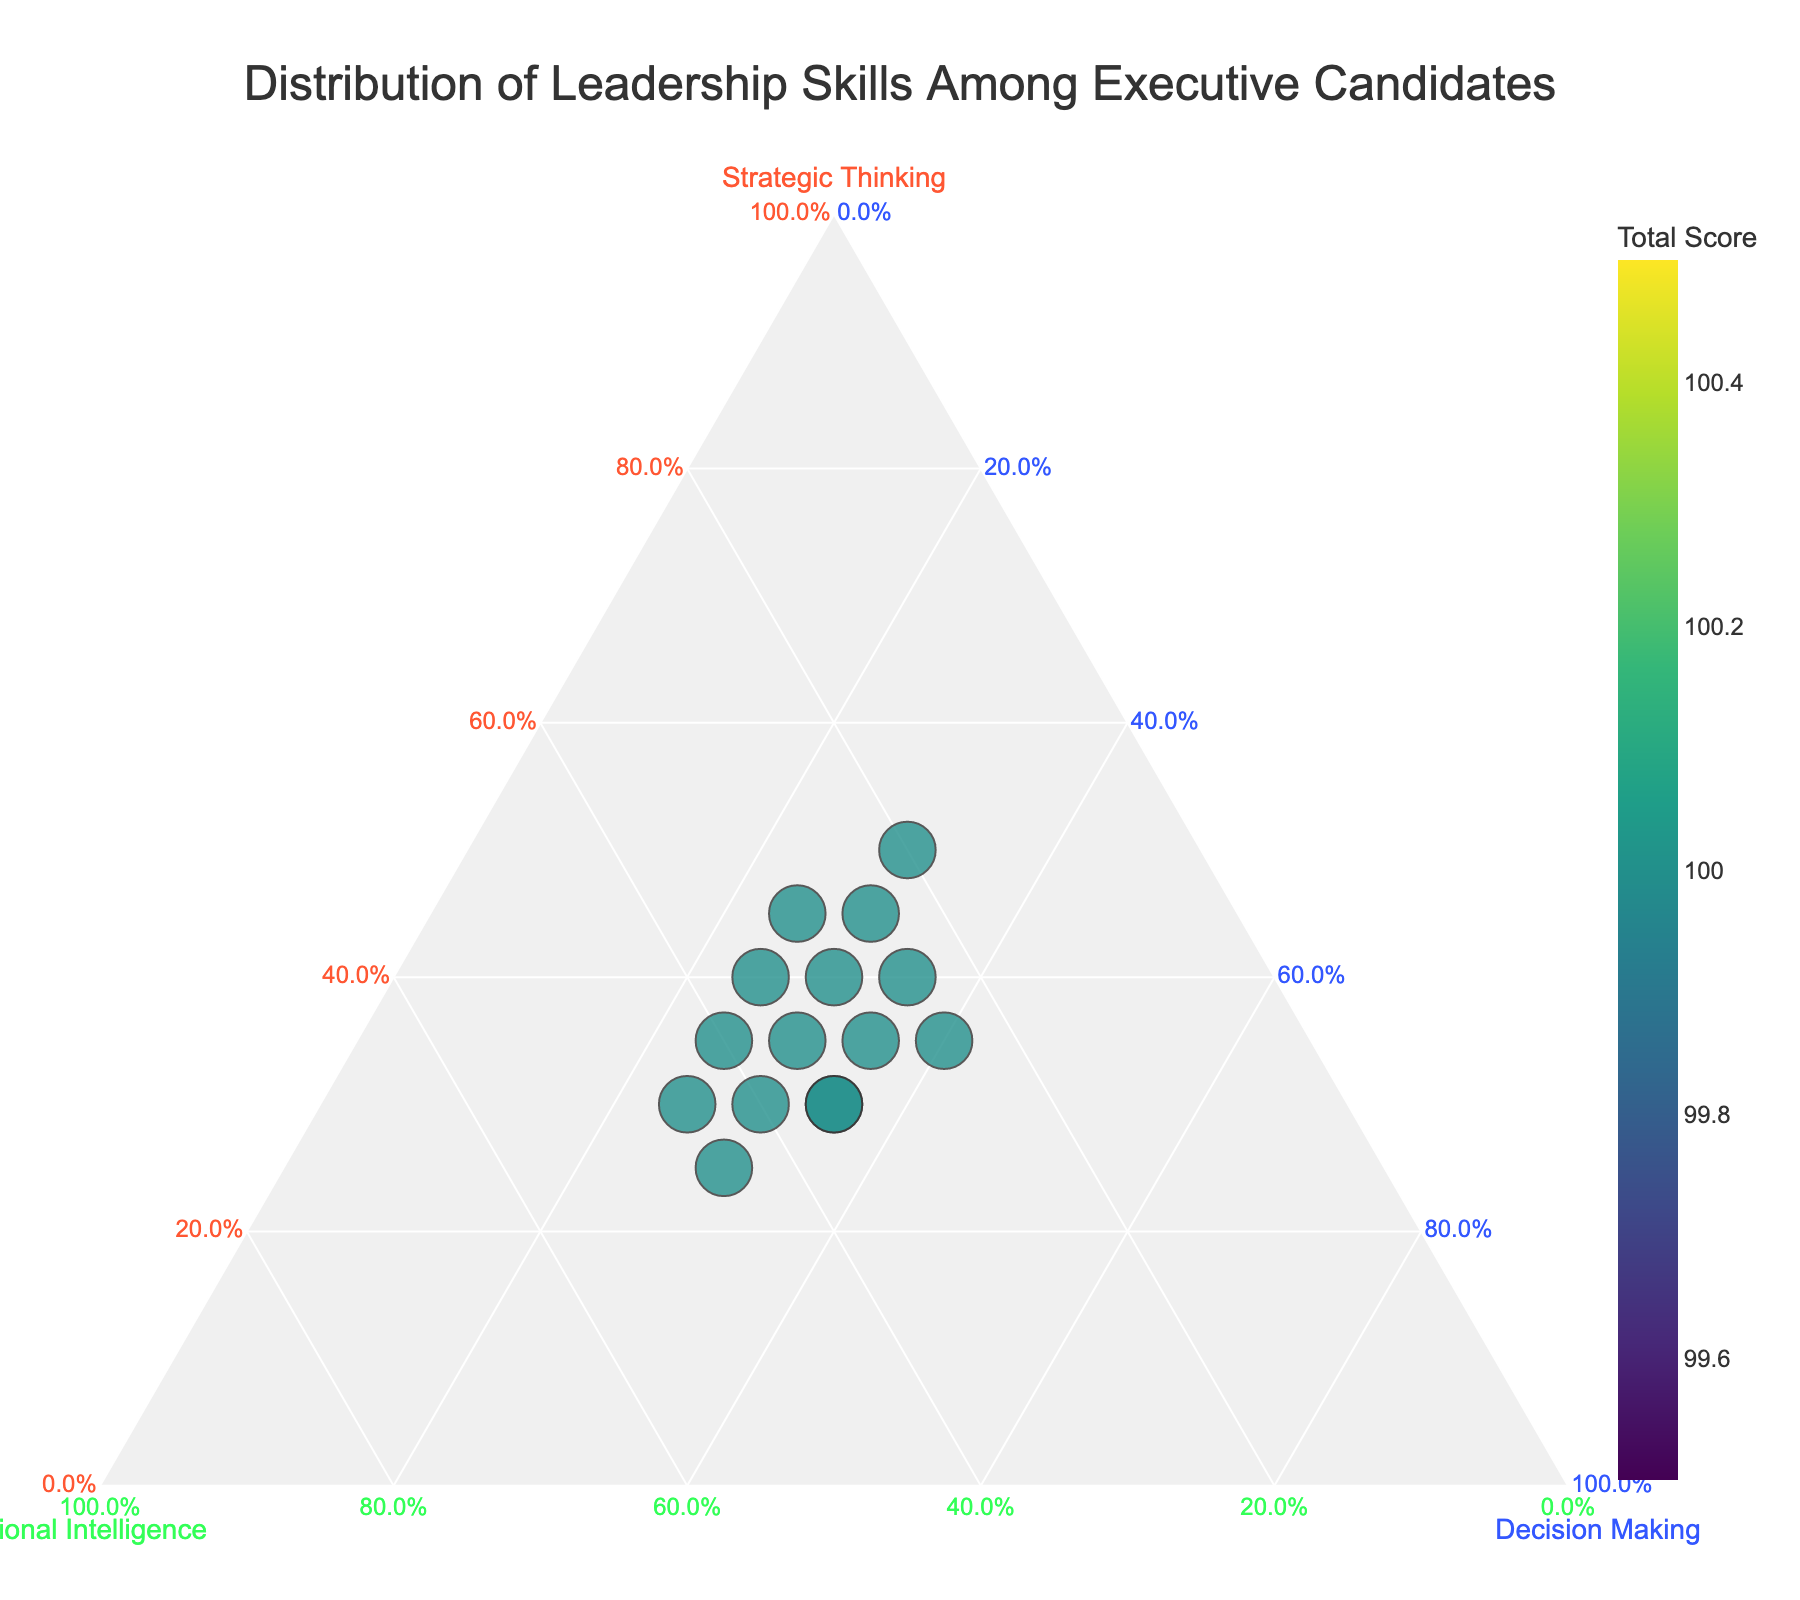What is the title of the plot? The title is prominently displayed at the top of the plot.
Answer: Distribution of Leadership Skills Among Executive Candidates How many total candidates are represented in the plot? The total number of data points (candidates) can be counted from the plot.
Answer: 15 Which axis represents Strategic Thinking? The axis labeled "Strategic Thinking" represents the Strategic Thinking component.
Answer: The left axis Which candidate has the highest combined total score? By checking the color scale and the size of the markers, which correspond to the total score, the candidate with the largest and darkest marker can be identified.
Answer: James Wilson Compare the skills distribution of Sarah Johnson and Michael Chen. Sarah Johnson and Michael Chen's positions on the plot can be examined and compared based on their coordinates on each axis. Sarah's strategic thinking is more prominent, Michael's emotional intelligence is higher, and their decision-making skills are equal.
Answer: Sarah: Higher Strategic Thinking, Michael: Higher Emotional Intelligence, Decision Making: Equal Which candidate has the highest proportion of Emotional Intelligence? By finding the candidate positioned furthest towards the Emotional Intelligence axis, the candidate with the highest proportion can be identified.
Answer: Natalie Kim How does Olivia Patel's skill distribution differ from Emma Garcia's? By locating Olivia Patel and Emma Garcia on the plot and comparing their relative positions to each axis. Olivia has equal strategic thinking and emotional intelligence, while Emma has higher strategic thinking.
Answer: Olivia: More balanced, Emma: Higher Strategic Thinking and lower Emotional Intelligence Identify the candidate with the lowest Decision-Making proportion. By searching for the candidate closest to the opposite side of the Decision-Making axis, the lowest proportion can be identified.
Answer: Sarah Johnson What can you infer about candidates with the largest markers on the plot? The largest markers indicate the highest total scores, suggesting these candidates have well-rounded leadership skills with high scores in the combination of strategic thinking, emotional intelligence, and decision-making.
Answer: They have well-rounded leadership skills and high total scores Which candidate’s skills cluster most closely around Decision-Making? By finding the candidate closest to the Decision-Making axis, it can be determined who has the majority of their skills in this area.
Answer: Marcus Williams 